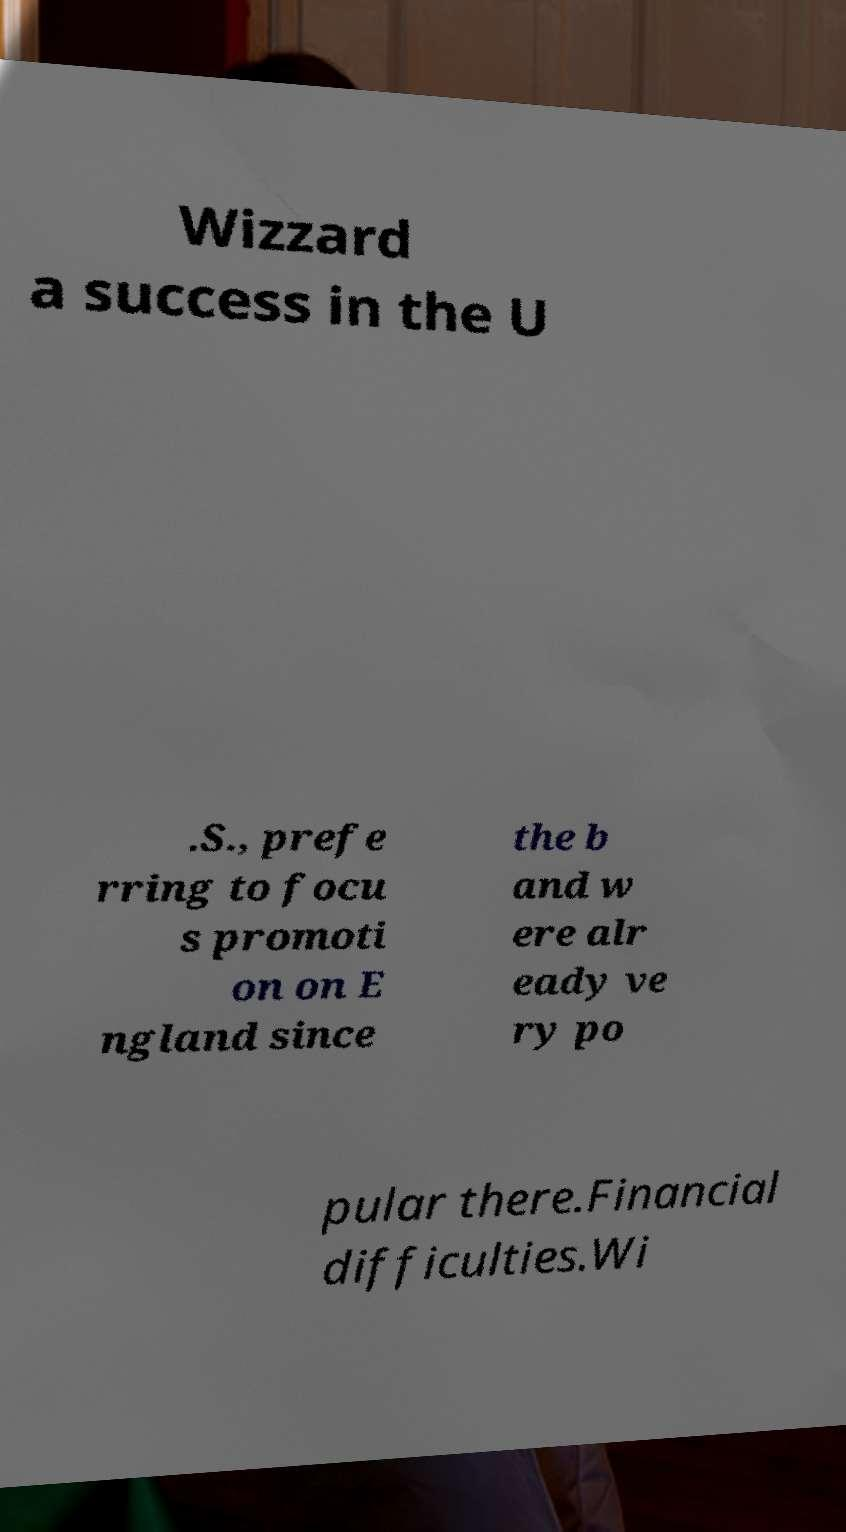Could you extract and type out the text from this image? Wizzard a success in the U .S., prefe rring to focu s promoti on on E ngland since the b and w ere alr eady ve ry po pular there.Financial difficulties.Wi 